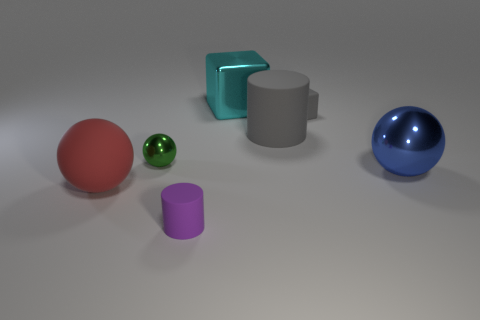Are there any small spheres that have the same material as the big red ball?
Provide a succinct answer. No. What shape is the big rubber thing that is in front of the rubber cylinder that is behind the big thing in front of the blue sphere?
Provide a short and direct response. Sphere. What material is the cyan object?
Keep it short and to the point. Metal. There is a ball that is the same material as the tiny purple cylinder; what is its color?
Ensure brevity in your answer.  Red. There is a big metallic object to the right of the big shiny cube; is there a purple thing right of it?
Offer a very short reply. No. How many other things are there of the same shape as the tiny metal thing?
Your response must be concise. 2. There is a cyan metal object that is on the left side of the large gray cylinder; is its shape the same as the tiny matte thing on the right side of the big metal block?
Your response must be concise. Yes. How many large cyan metal cubes are behind the block in front of the metal object behind the big gray thing?
Give a very brief answer. 1. What color is the small rubber cube?
Provide a succinct answer. Gray. What number of other objects are there of the same size as the purple cylinder?
Keep it short and to the point. 2. 